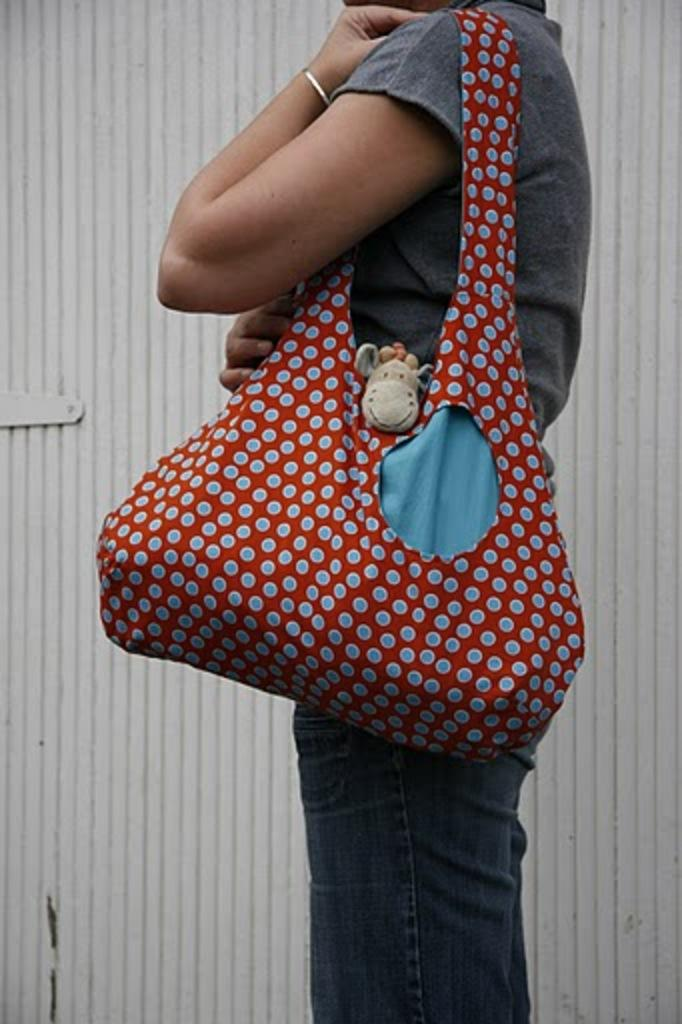What is the main subject of the image? There is a person in the image. What is the person doing in the image? The person is standing. What is the person wearing in the image? The person is wearing a bag. What type of quilt is being used by the person in the image? There is no quilt present in the image. What emotion is the person displaying in the image? The image does not show any specific emotion or fear. 